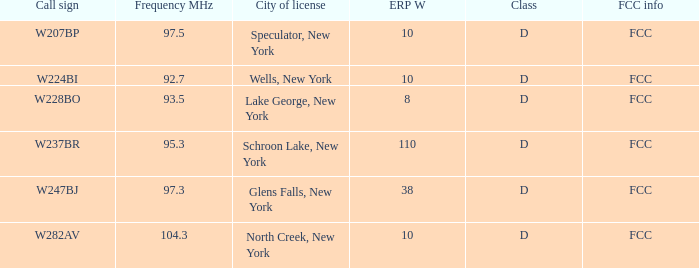Name the average ERP W and call sign of w237br 110.0. 